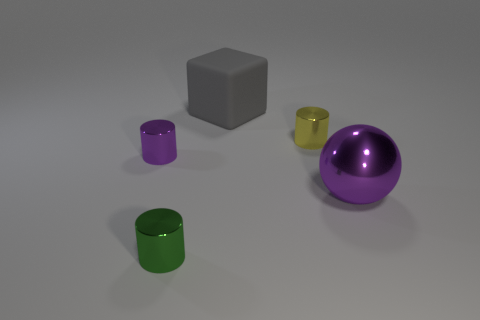How do the colors of the objects in the image relate to each other? The objects present a variety of colors that are distinct yet harmonious. The green, purple, yellow, and grey hues don't clash, creating a visually appealing palette. The repetition of the purple color in both the cylinder and the ball contributes to the sense of cohesion in the image. 